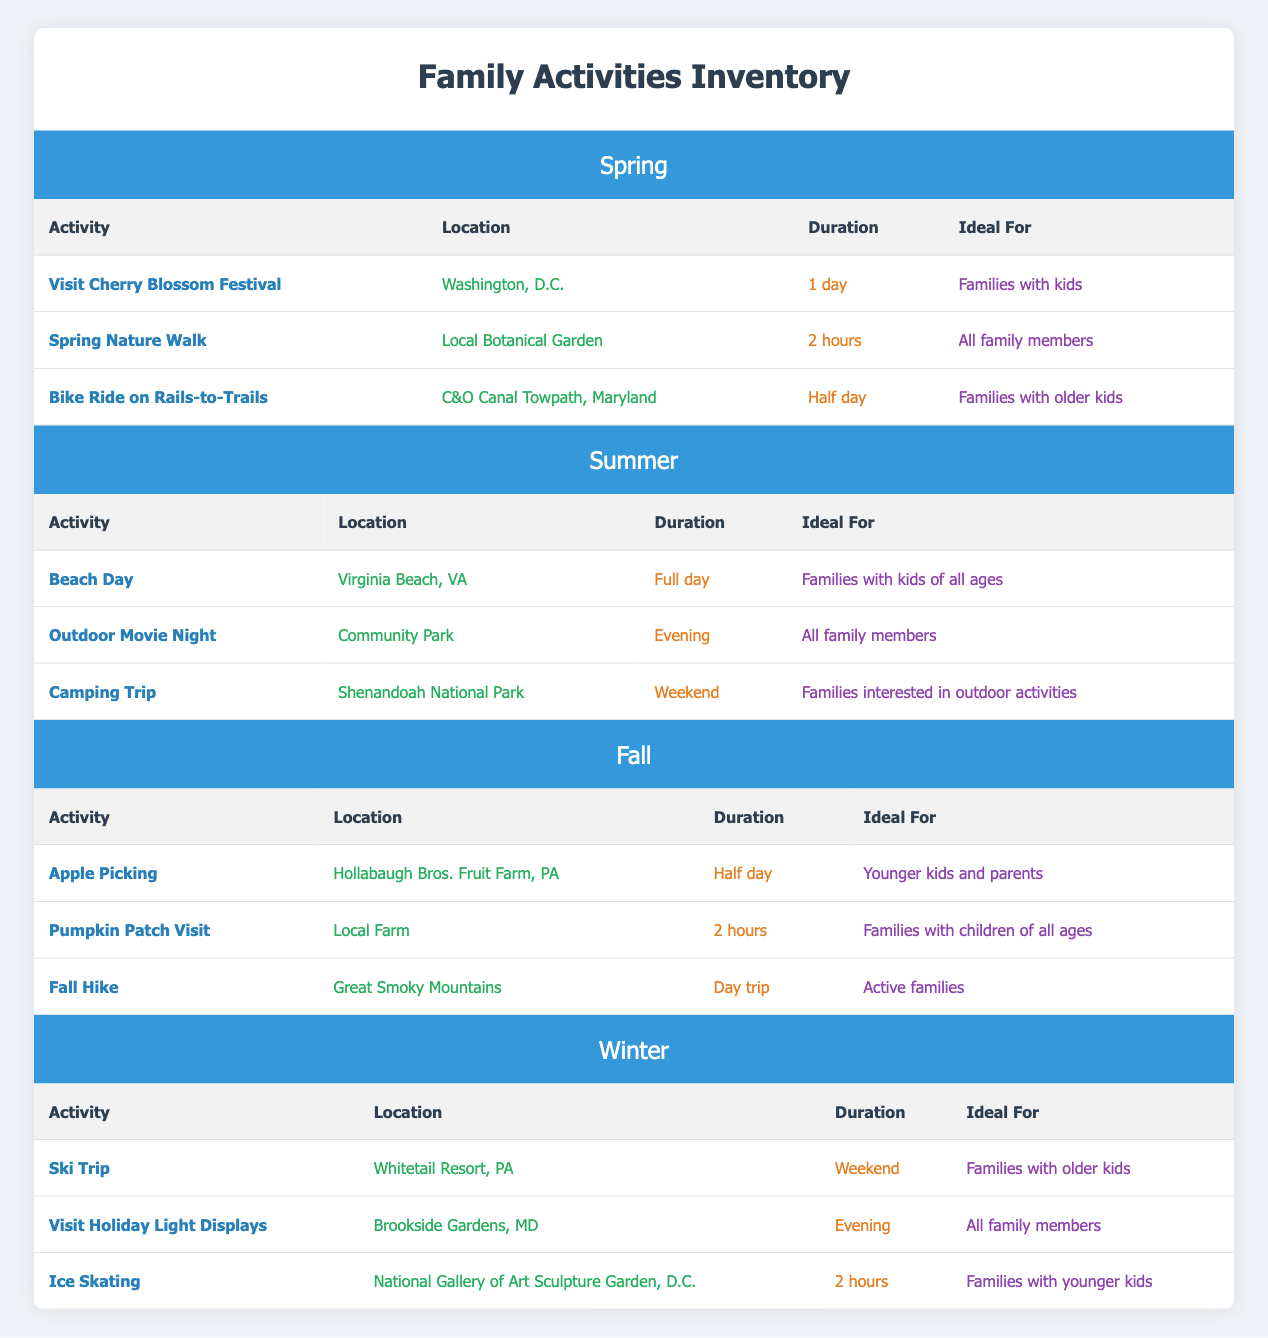What is the location for the "Pumpkin Patch Visit"? From the table under the Fall section, the location for the "Pumpkin Patch Visit" is listed as "Local Farm."
Answer: Local Farm How long does the "Ski Trip" last? The duration for the "Ski Trip" activity, as per the Winter section of the table, is specified as a "Weekend."
Answer: Weekend Are the "Beach Day" and "Camping Trip" ideal for all family members? The "Beach Day" is ideal for "Families with kids of all ages," while the "Camping Trip" is ideal for "Families interested in outdoor activities," so not both are ideal for all family members.
Answer: No Which season has the least number of activities in the inventory? Comparing the number of activities across all seasons: Spring (3), Summer (3), Fall (3), Winter (3). All seasons have the same number, so none has fewer.
Answer: None What is the average duration of activities available in the Spring season? The durations for Spring activities are: 1 day, 2 hours (which can be represented as 1/12 day), and half day. Converting to hours, the total is (24 + 2 + 6) = 32 hours. As there are 3 activities, the average duration is 32/3 = approximately 10.67 hours, or about 10 hours and 40 minutes.
Answer: Approximately 10 hours and 40 minutes How many activities are ideal for younger kids? The table shows that "Ice Skating" and "Apple Picking" are ideal for younger kids, totaling 2 activities.
Answer: 2 Is the "Visit Cherry Blossom Festival" only for families with kids? The "Visit Cherry Blossom Festival" is ideal for "Families with kids," which means it is not suitable for families without kids.
Answer: Yes Which activity has the longest duration? The "Beach Day" has a duration of "Full day," which is longer than any other activities listed.
Answer: Beach Day How many activities are categorized for active families? The table specifies that "Fall Hike" is ideal for "Active families," which is the only activity listed for this category. Therefore, there is only 1 activity for active families.
Answer: 1 